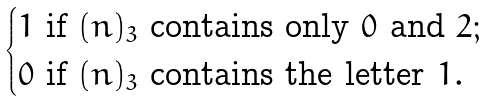<formula> <loc_0><loc_0><loc_500><loc_500>\begin{cases} 1 \text { if } ( n ) _ { 3 } \text { contains only } 0 \text { and } 2 ; \\ 0 \text { if } ( n ) _ { 3 } \text { contains the letter } 1 . \end{cases}</formula> 